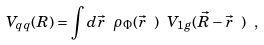<formula> <loc_0><loc_0><loc_500><loc_500>V _ { q q } ( R ) = \int d \vec { r } \ \rho _ { \Phi } ( \vec { r } \ ) \ V _ { 1 g } ( \vec { R } - \vec { r } \ ) \ ,</formula> 